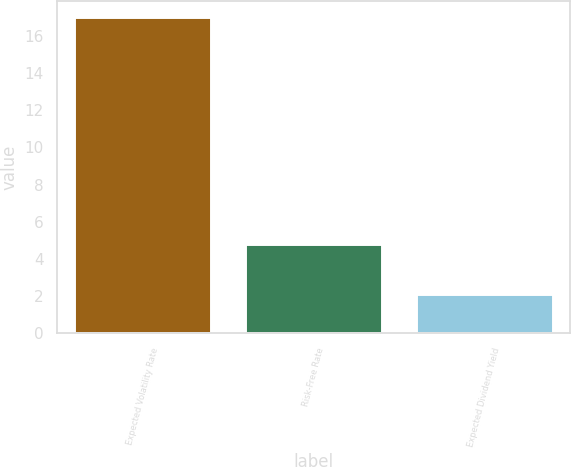Convert chart. <chart><loc_0><loc_0><loc_500><loc_500><bar_chart><fcel>Expected Volatility Rate<fcel>Risk-Free Rate<fcel>Expected Dividend Yield<nl><fcel>17<fcel>4.8<fcel>2.1<nl></chart> 